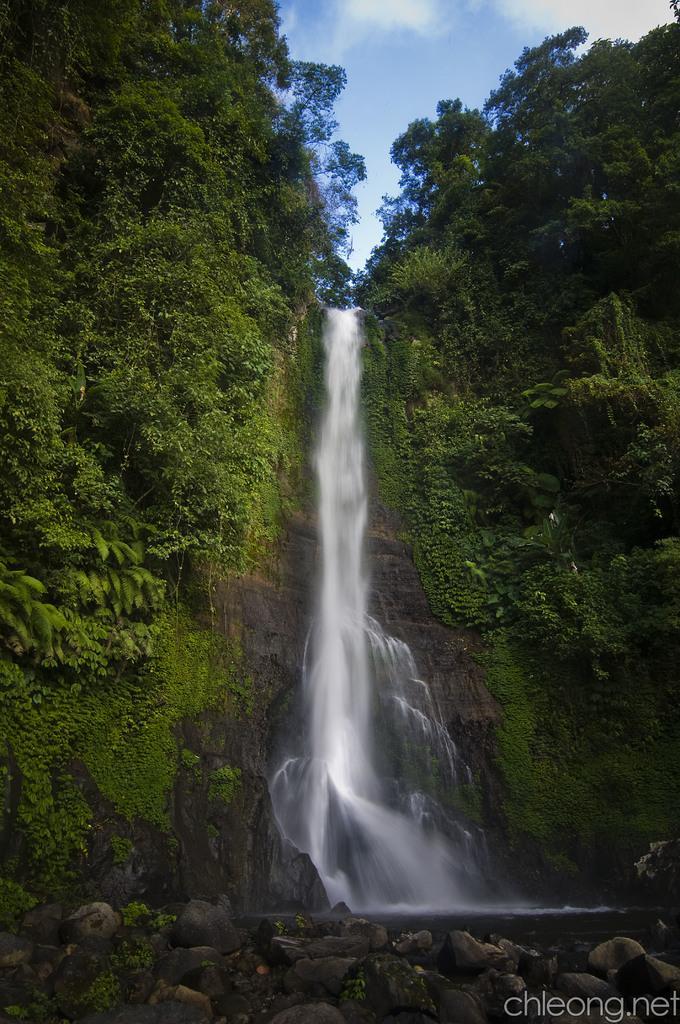In one or two sentences, can you explain what this image depicts? In this image, we can see the waterfall. There are some trees. We can see some algae, rocks and some plants. We can see some text written on the bottom right. We can see the sky with clouds. 